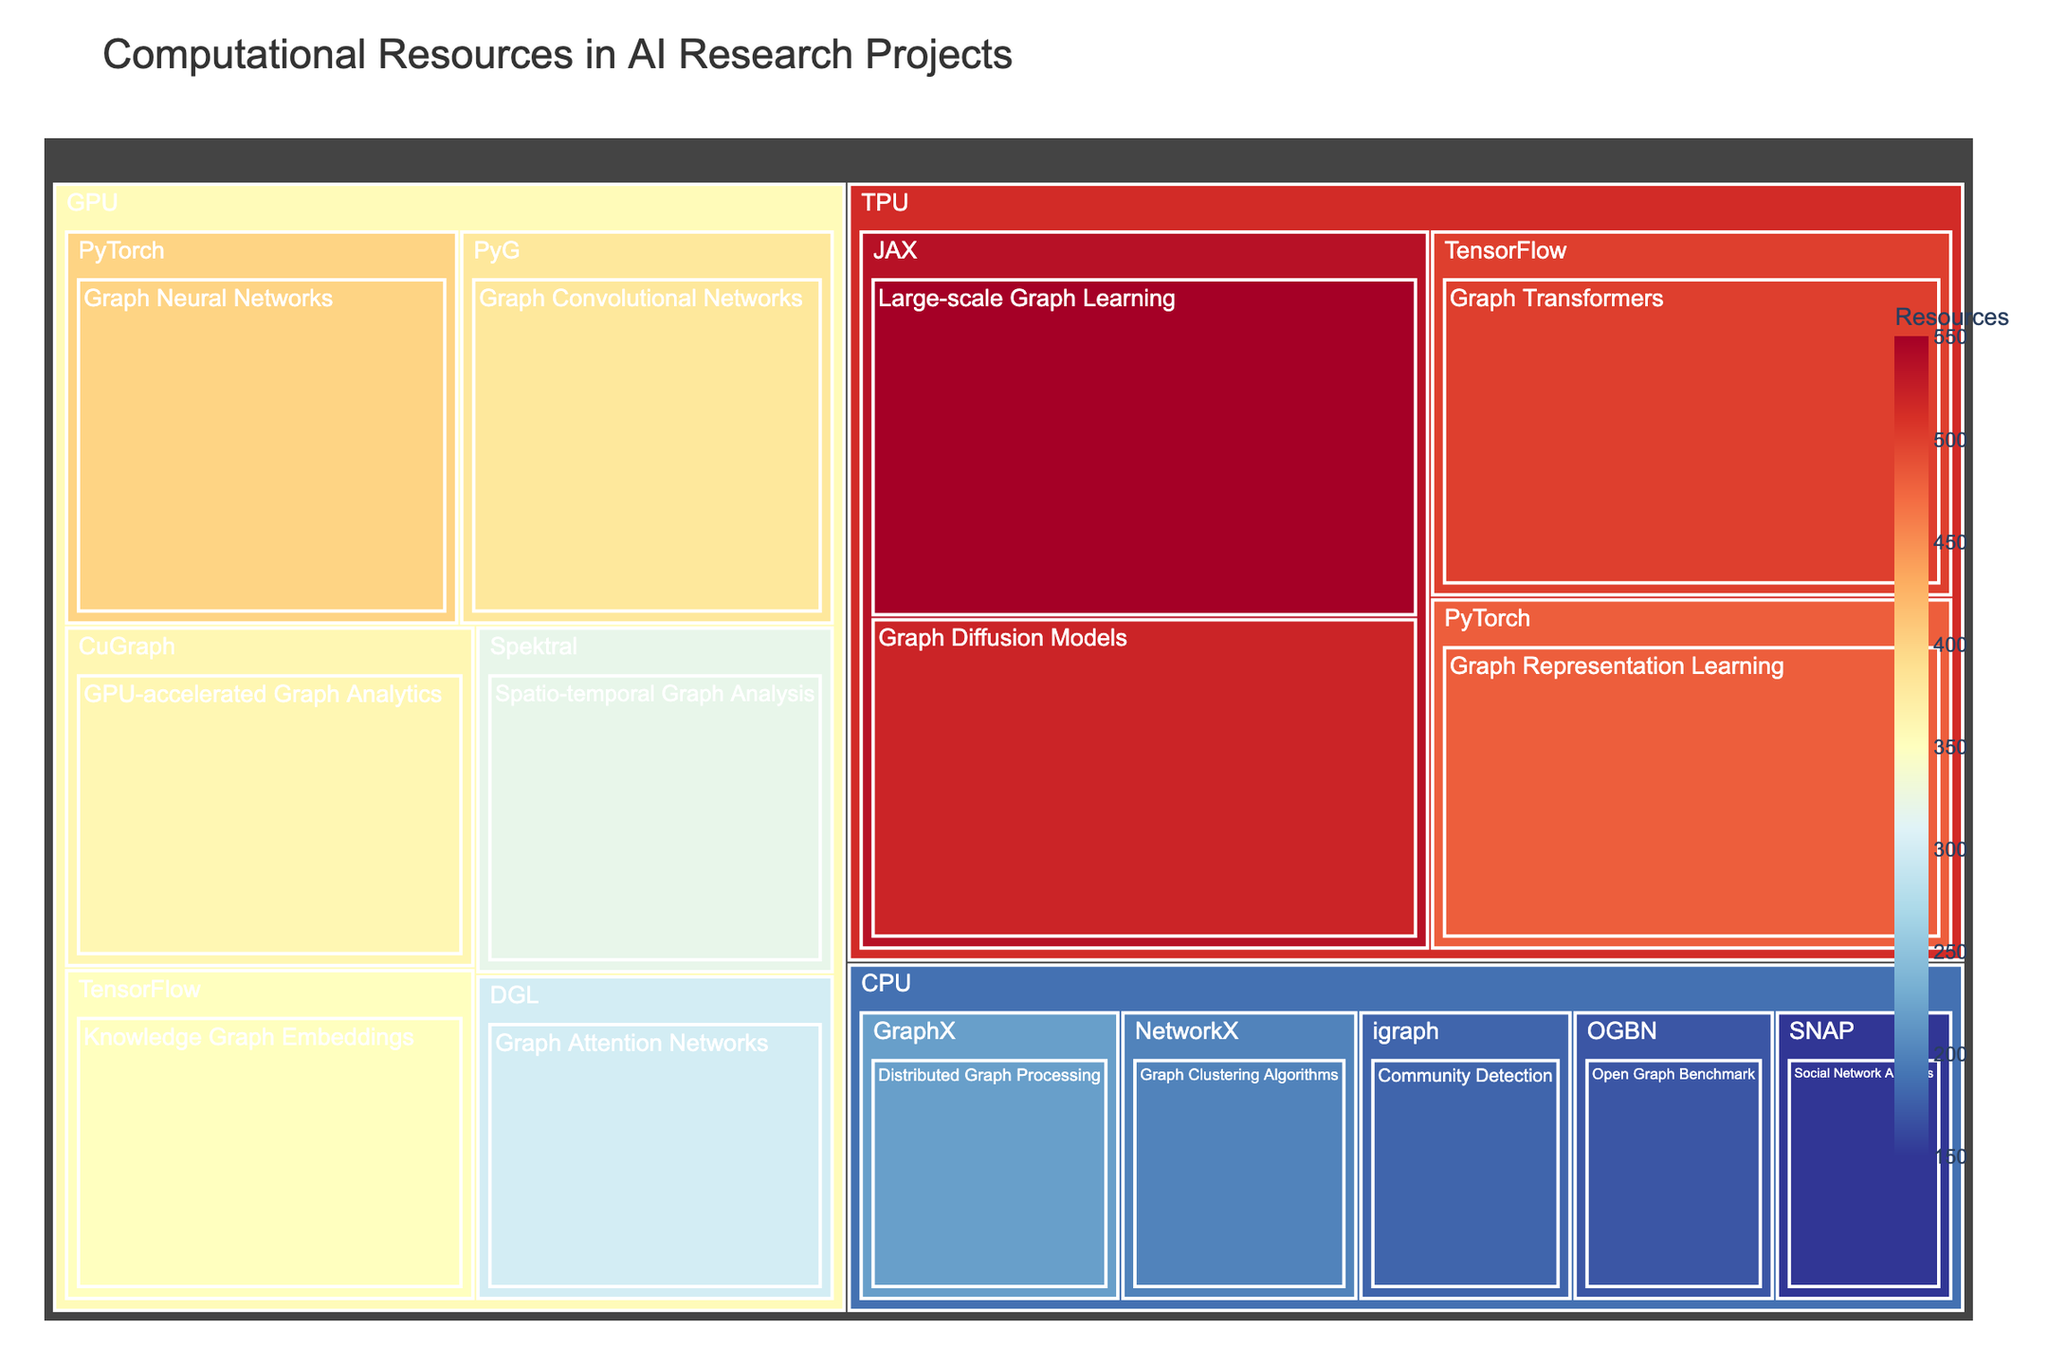What is the title of the treemap? The title of the treemap is shown at the top. By reading it, we can determine it is "Computational Resources in AI Research Projects".
Answer: Computational Resources in AI Research Projects Which hardware type uses the most resources? By looking at the hierarchical data and summing up the resources used within each hardware category, we find that TPUs use the most resources.
Answer: TPU How many projects utilize GPUs? We identify the sections marked under the GPU hardware type and count the individual projects listed. There are six projects under GPU.
Answer: 6 Which software framework under CPU-based hardware uses the most resources? By examining the sections under CPU, we see the software frameworks listed (NetworkX, SNAP, igraph, GraphX, OGBN) and their corresponding resource values. NetworkX has the highest value at 200.
Answer: NetworkX What is the total computational resources used by TPU-associated projects? Add the resource values from all TPU-based projects (550 + 500 + 480 + 520). This calculation gives the total resources for TPUs.
Answer: 2050 Which project utilizes the least computational resources? The smallest block within the treemap represents the project with the least resources. "Social Network Analysis" under CPU (SNAP) uses 150 units of resources.
Answer: Social Network Analysis Compare the resources used by PyTorch with JAX. Which one has the higher total? From the tree, sum the resources utilized by projects using PyTorch (400 + 480). Then, sum the resources for projects using JAX (550 + 520). PyTorch uses 880, while JAX uses 1070. JAX has a higher total.
Answer: JAX How many CPU-based projects are there? By inspecting the blocks under the CPU category in the treemap, we count each project listed. There are a total of five projects.
Answer: 5 What is the average computational resource usage for GPU-based projects? The sum of the resources for GPU-based projects is 400 + 350 + 300 + 380 + 320 + 360 = 2110. There are 6 GPU-based projects, so the average is 2110 / 6 = 351.67.
Answer: 351.67 Which hardware-software combination uses the highest resources? Look for the largest block that descends from a specific hardware and software combination. The "Large-scale Graph Learning" project under TPU and JAX uses 550 units, which is the highest.
Answer: TPU and JAX 